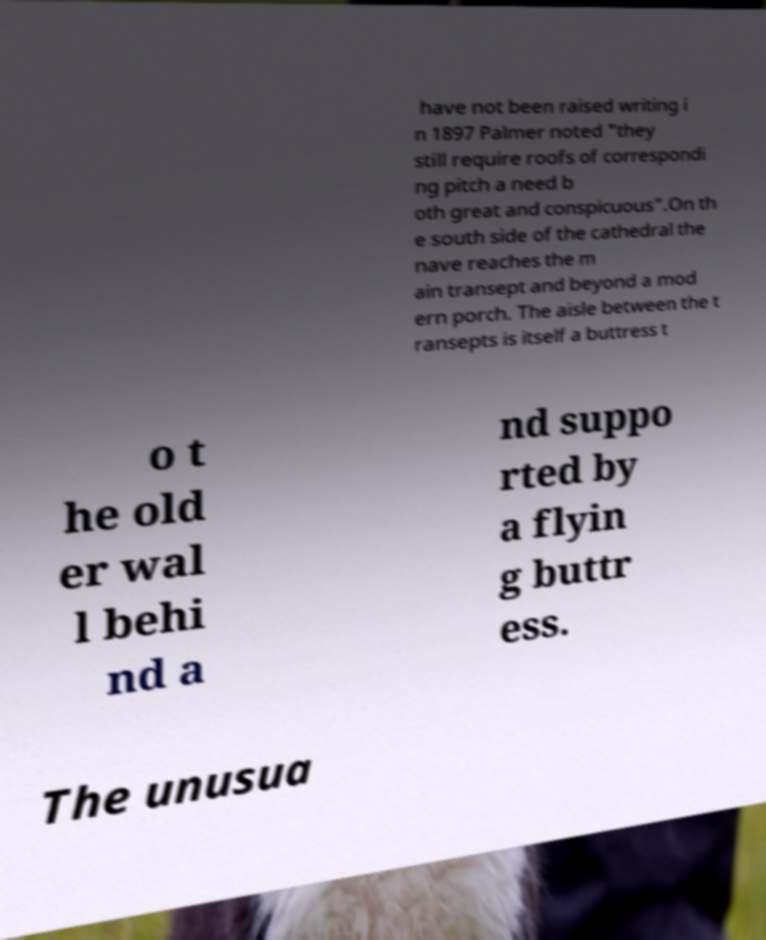Can you read and provide the text displayed in the image?This photo seems to have some interesting text. Can you extract and type it out for me? have not been raised writing i n 1897 Palmer noted "they still require roofs of correspondi ng pitch a need b oth great and conspicuous".On th e south side of the cathedral the nave reaches the m ain transept and beyond a mod ern porch. The aisle between the t ransepts is itself a buttress t o t he old er wal l behi nd a nd suppo rted by a flyin g buttr ess. The unusua 